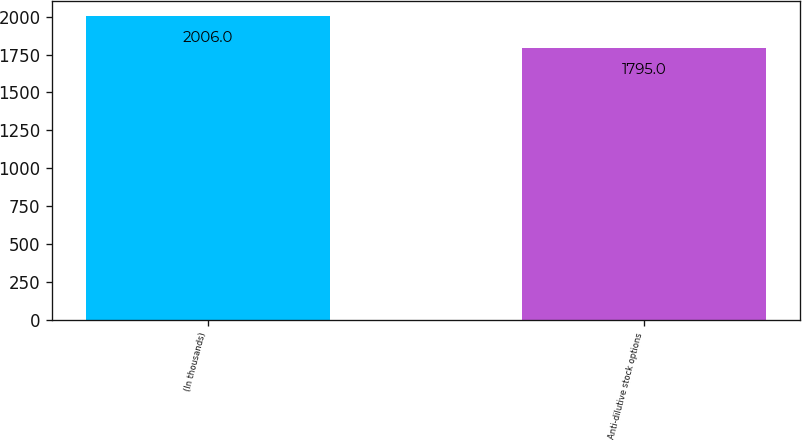Convert chart. <chart><loc_0><loc_0><loc_500><loc_500><bar_chart><fcel>(In thousands)<fcel>Anti-dilutive stock options<nl><fcel>2006<fcel>1795<nl></chart> 